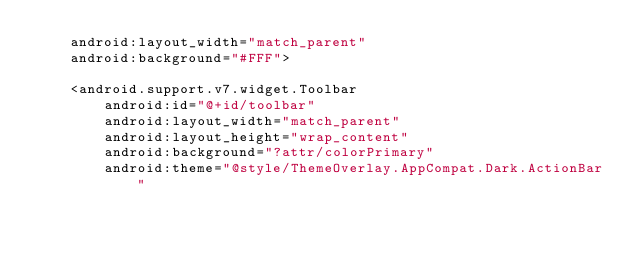Convert code to text. <code><loc_0><loc_0><loc_500><loc_500><_XML_>    android:layout_width="match_parent"
    android:background="#FFF">

    <android.support.v7.widget.Toolbar
        android:id="@+id/toolbar"
        android:layout_width="match_parent"
        android:layout_height="wrap_content"
        android:background="?attr/colorPrimary"
        android:theme="@style/ThemeOverlay.AppCompat.Dark.ActionBar"</code> 